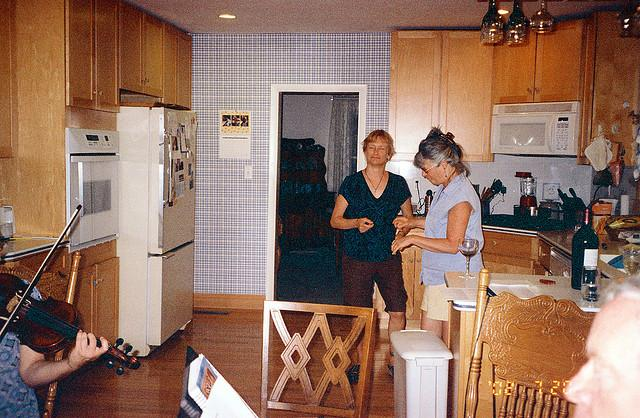What instrument is the person on the left playing? Please explain your reasoning. violin. It is being held on the shoulder in a certain manner that is only used to play a violin. 